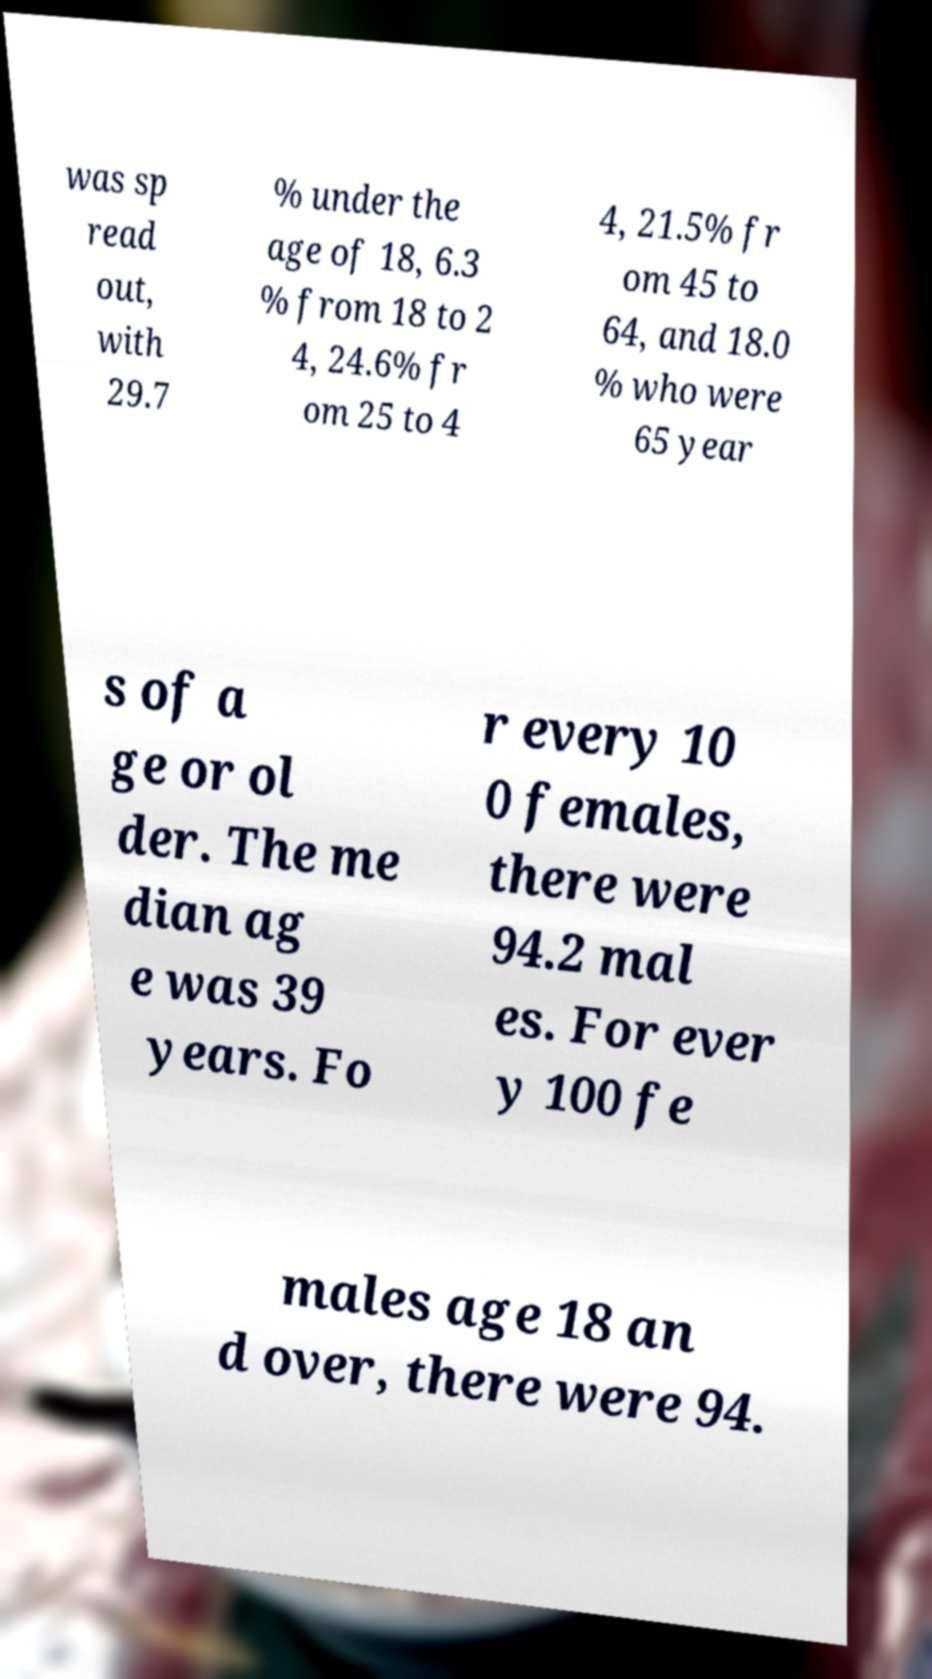Can you read and provide the text displayed in the image?This photo seems to have some interesting text. Can you extract and type it out for me? was sp read out, with 29.7 % under the age of 18, 6.3 % from 18 to 2 4, 24.6% fr om 25 to 4 4, 21.5% fr om 45 to 64, and 18.0 % who were 65 year s of a ge or ol der. The me dian ag e was 39 years. Fo r every 10 0 females, there were 94.2 mal es. For ever y 100 fe males age 18 an d over, there were 94. 